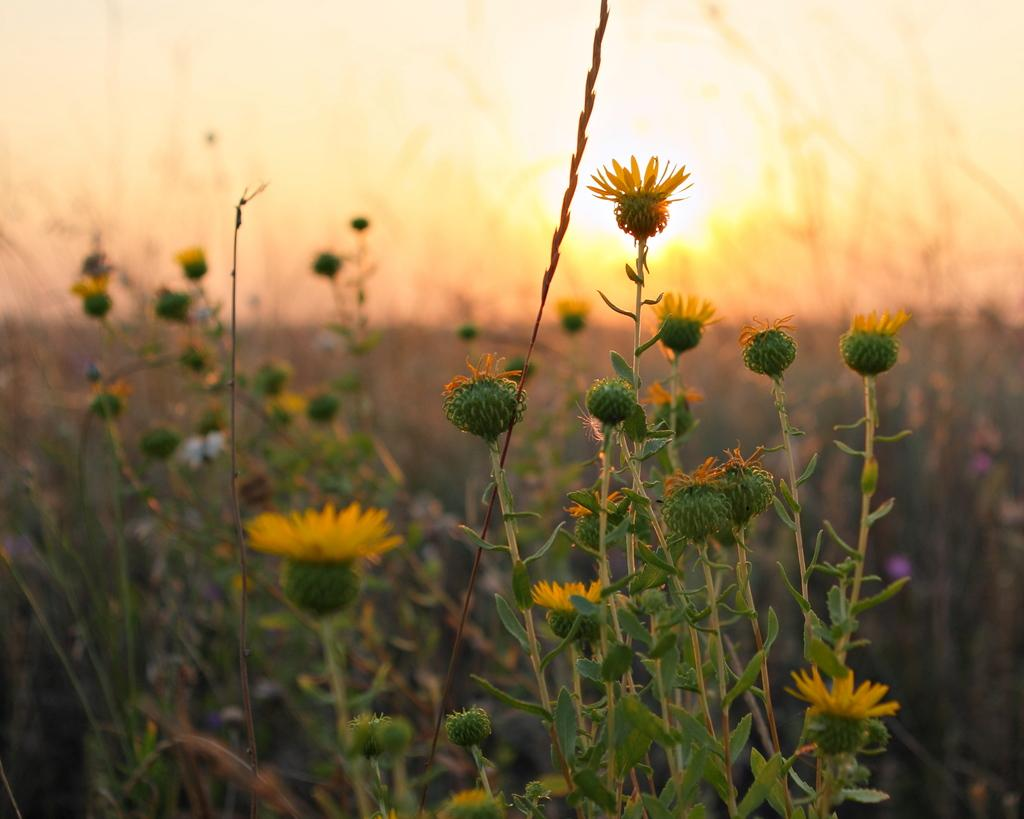What color are the flowers on the plants in the image? The flowers on the plants are yellow. What stage of growth are the plants in? The plants have buds, indicating they are in the process of blooming. What is visible at the top of the image? The sky is visible at the top of the image. Can the sun be seen in the sky? Yes, the sun is observable in the sky. What type of chair can be seen in the image? There is no chair present in the image; it features yellow flowers on plants with buds, a visible sky, and the sun. What shape is the learning process depicted in the image? There is no learning process depicted in the image; it focuses on the plants and their flowers. 